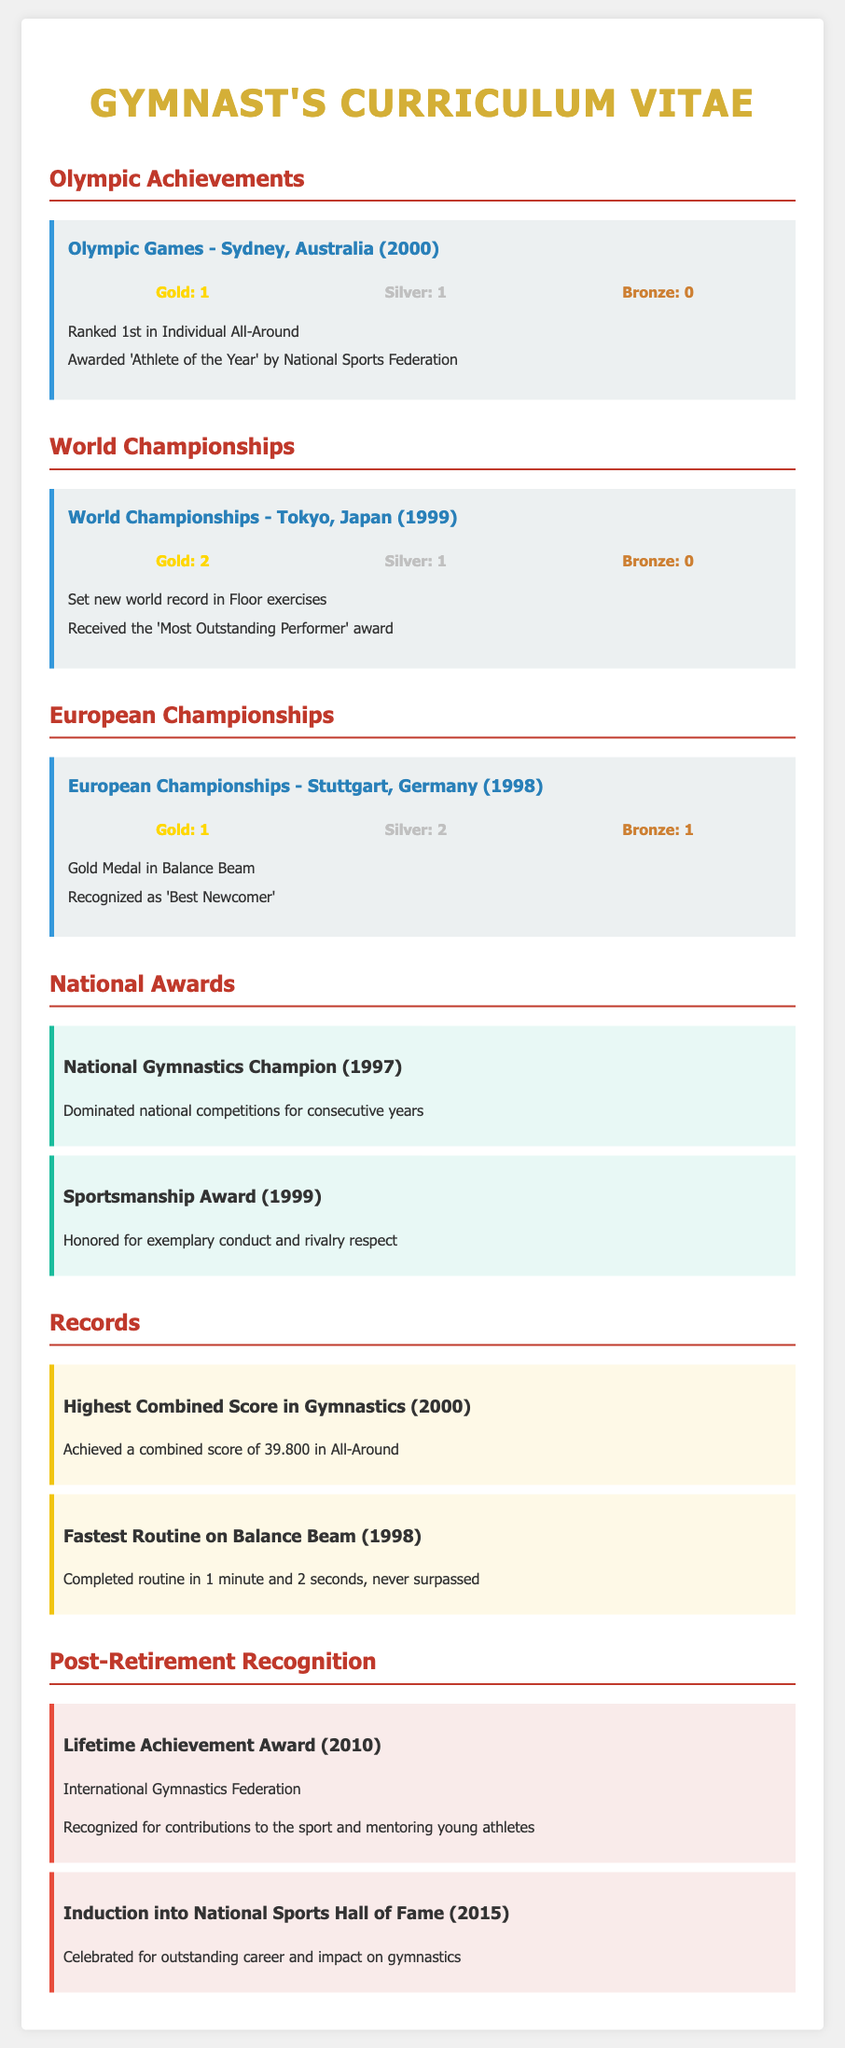What medals were won at the Sydney Olympics? The document specifies the medals won at the Sydney Olympics, which include 1 Gold and 1 Silver.
Answer: 1 Gold, 1 Silver How many gold medals were won at the World Championships in 1999? The document lists the medals won at the World Championships in 1999, detailing 2 Gold medals.
Answer: 2 Gold What year was the 'Most Outstanding Performer' award received? The award was received during the World Championships in 1999, as stated in the document.
Answer: 1999 What is the highest combined score achieved in All-Around? The document notes that the highest combined score achieved was 39.800 in All-Around.
Answer: 39.800 Which award was given for exemplary conduct in rivalry? The document states the Sportsmanship Award was given for exemplary conduct and rivalry respect.
Answer: Sportsmanship Award How many total medals were earned in the European Championships in 1998? The document lists the medals earned at the European Championships in 1998 and adds them: 1 Gold, 2 Silver, and 1 Bronze, totaling 4 medals.
Answer: 4 Medals What notable achievement occurred in 2000? The document highlights the achievement of the Highest Combined Score in Gymnastics in the year 2000.
Answer: Highest Combined Score When was the Lifetime Achievement Award received? According to the document, the Lifetime Achievement Award was received in 2010.
Answer: 2010 What recognition was received in 2015? The document indicates that the Induction into National Sports Hall of Fame was received in 2015.
Answer: Induction into National Sports Hall of Fame 